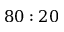Convert formula to latex. <formula><loc_0><loc_0><loc_500><loc_500>8 0 \colon 2 0</formula> 